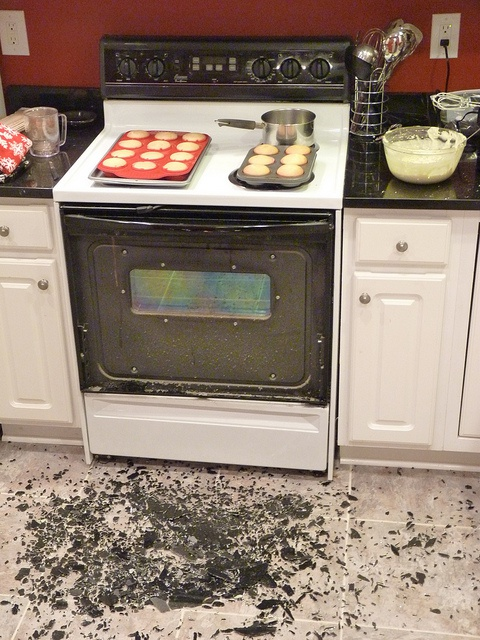Describe the objects in this image and their specific colors. I can see oven in maroon, black, lightgray, gray, and tan tones, bowl in maroon, khaki, tan, lightyellow, and gray tones, cup in maroon, gray, darkgray, and tan tones, spoon in maroon, gray, and tan tones, and bowl in maroon, black, and gray tones in this image. 